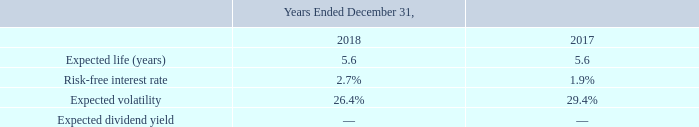The fair value of options granted in the respective fiscal years are estimated on the date of grant using the Black-Scholes optionpricing model, acceptable under ASC 718, with the following weighted average assumptions:
Expected volatilities are based on the Company’s historical common stock volatility, derived from historical stock price data for periods commensurate with the options’ expected life. The expected life of options granted represents the period of time options are expected to be outstanding, based primarily on historical employee option exercise behavior. The risk-free interest rate is based on the implied yield currently available on U.S. Treasury zero coupon bonds issued with a term equal to the expected life at the date of grant of the options. The expected dividend yield is zero, as the Company has historically paid no dividends and does not anticipate dividends to be paid in the future.
What was the expected life (years) in 2018? 5.6. What was the risk-free interest rate in 2018? 2.7%. What was the risk-free interest rate in 2017? 1.9%. What was the change in Expected volatility between 2017 and 2018?
Answer scale should be: percent. 26.4%-29.4%
Answer: -3. What was the change in risk-free interest rate between 2017 and 2018?
Answer scale should be: percent. 2.7%-1.9%
Answer: 0.8. What was risk-free interest rate in 2017 as a percentage of risk-free interest rate in 2018?
Answer scale should be: percent. 1.9/2.7
Answer: 70.37. 